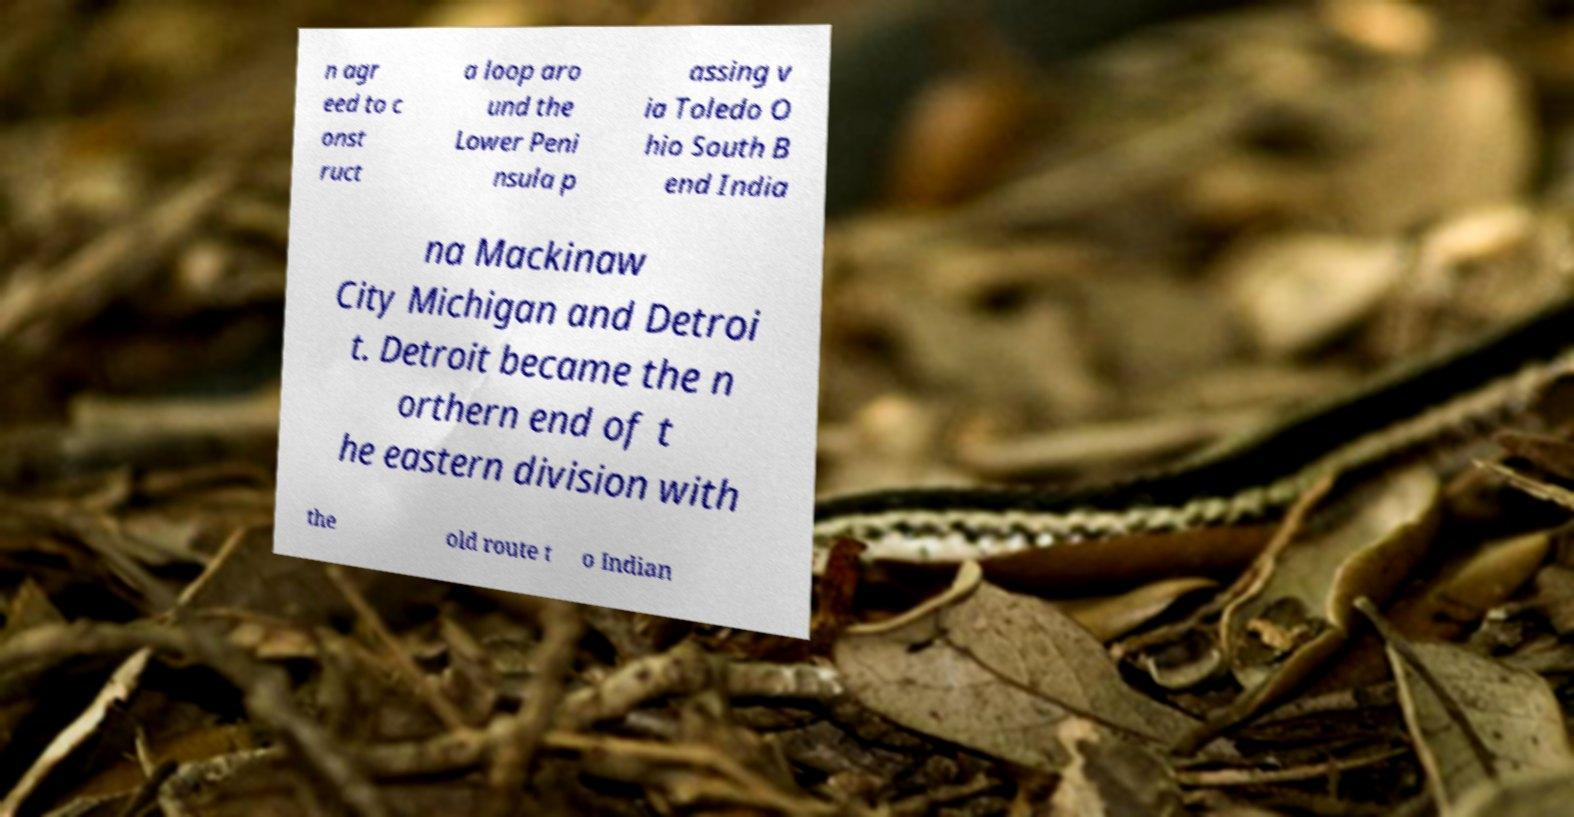Can you accurately transcribe the text from the provided image for me? n agr eed to c onst ruct a loop aro und the Lower Peni nsula p assing v ia Toledo O hio South B end India na Mackinaw City Michigan and Detroi t. Detroit became the n orthern end of t he eastern division with the old route t o Indian 